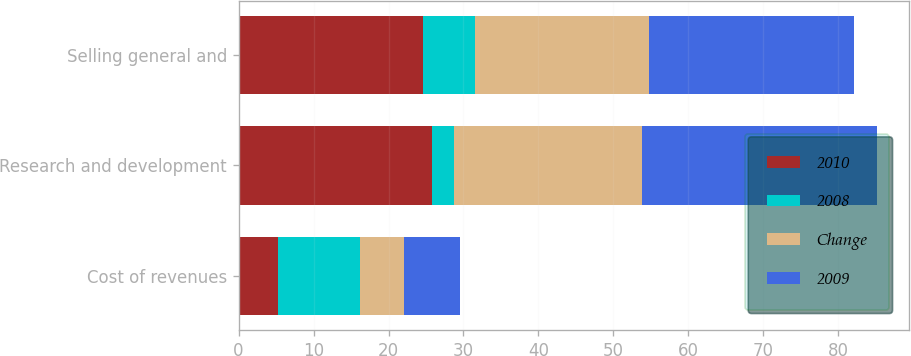Convert chart to OTSL. <chart><loc_0><loc_0><loc_500><loc_500><stacked_bar_chart><ecel><fcel>Cost of revenues<fcel>Research and development<fcel>Selling general and<nl><fcel>2010<fcel>5.2<fcel>25.8<fcel>24.6<nl><fcel>2008<fcel>11<fcel>3<fcel>7<nl><fcel>Change<fcel>5.8<fcel>25<fcel>23.1<nl><fcel>2009<fcel>7.6<fcel>31.4<fcel>27.4<nl></chart> 